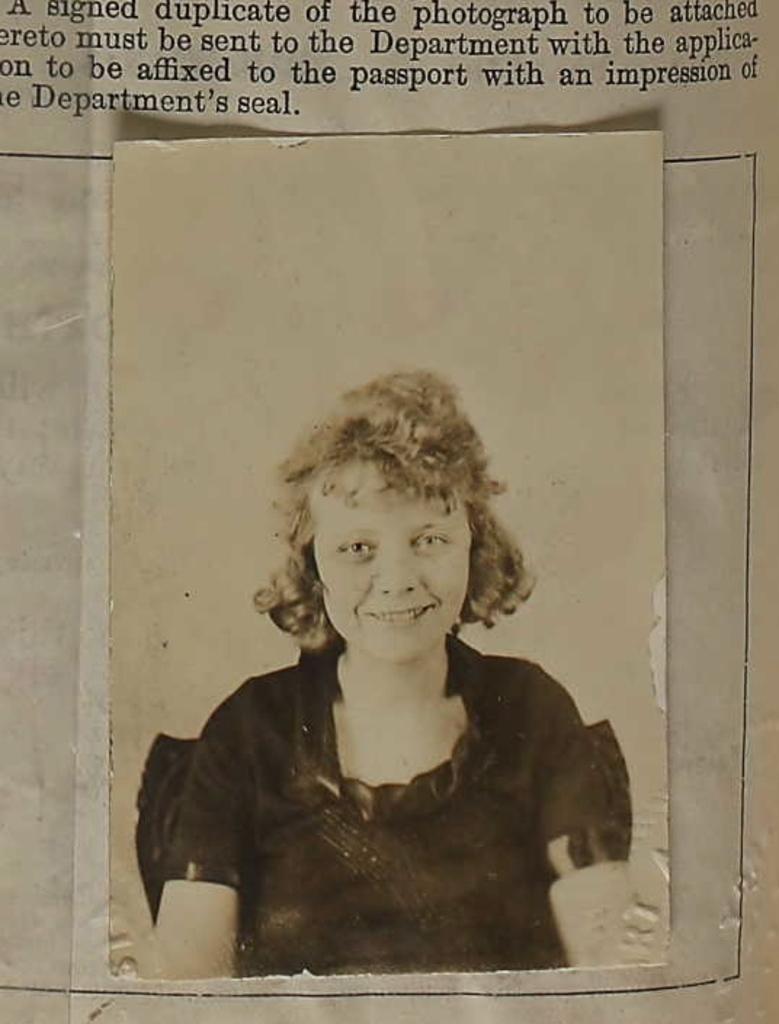Please provide a concise description of this image. In the image there is some text on a paper and under the text there is a photo of a person attached on the paper. 